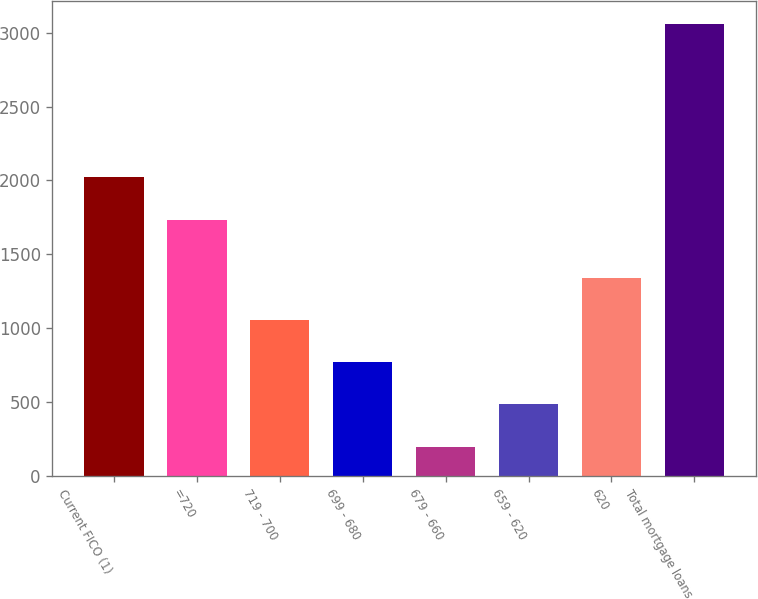Convert chart to OTSL. <chart><loc_0><loc_0><loc_500><loc_500><bar_chart><fcel>Current FICO (1)<fcel>=720<fcel>719 - 700<fcel>699 - 680<fcel>679 - 660<fcel>659 - 620<fcel>620<fcel>Total mortgage loans<nl><fcel>2020.3<fcel>1734<fcel>1055.9<fcel>769.6<fcel>197<fcel>483.3<fcel>1342.2<fcel>3060<nl></chart> 